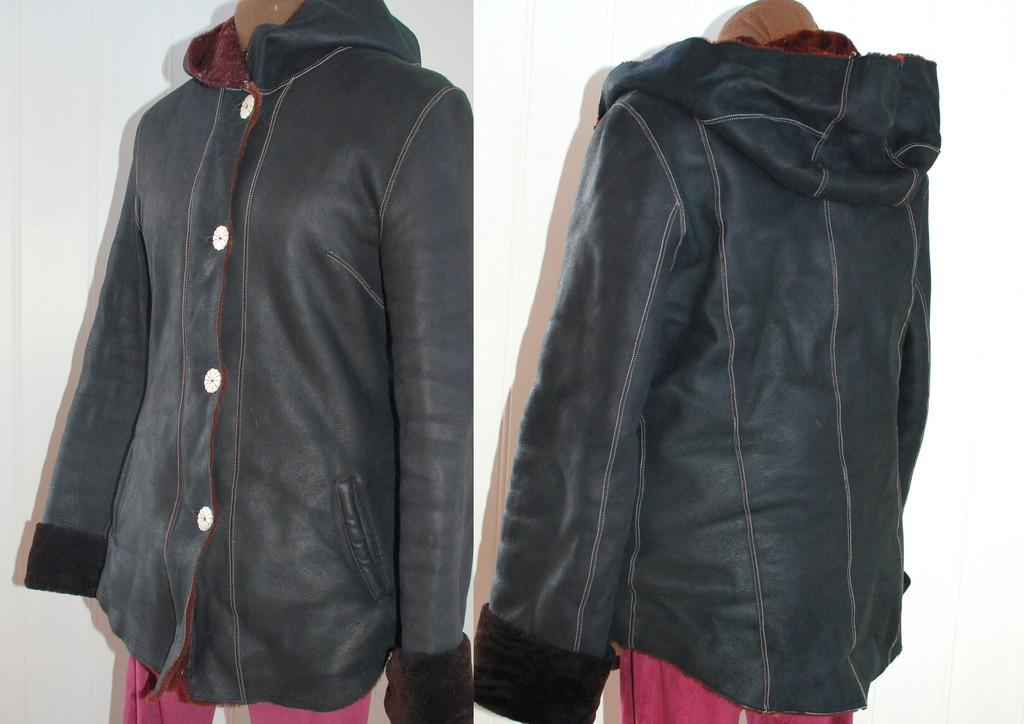What type of images are present in the image? There are two collage photos in the image. What is featured in the first collage photo? The first collage photo features a jacket. What is featured in the second collage photo? The second collage photo features a pink cloth. What type of noise can be heard coming from the jacket in the image? There is no noise present in the image, as it is a still collage featuring a jacket and a pink cloth. 